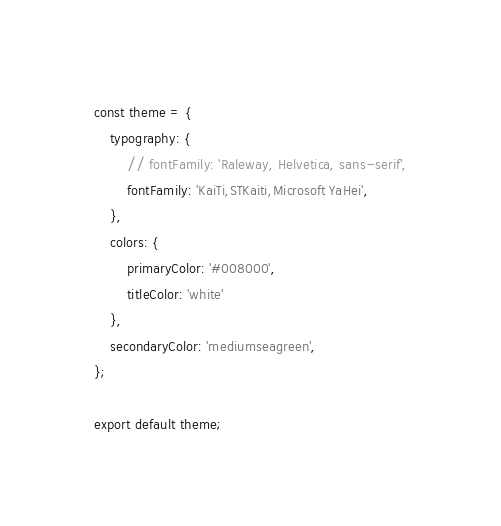Convert code to text. <code><loc_0><loc_0><loc_500><loc_500><_JavaScript_>const theme = {
	typography: {
		// fontFamily: 'Raleway, Helvetica, sans-serif',
		fontFamily: 'KaiTi,STKaiti,Microsoft YaHei',
	},
	colors: {
		primaryColor: '#008000',
		titleColor: 'white'
	},
	secondaryColor: 'mediumseagreen',
};

export default theme;
</code> 